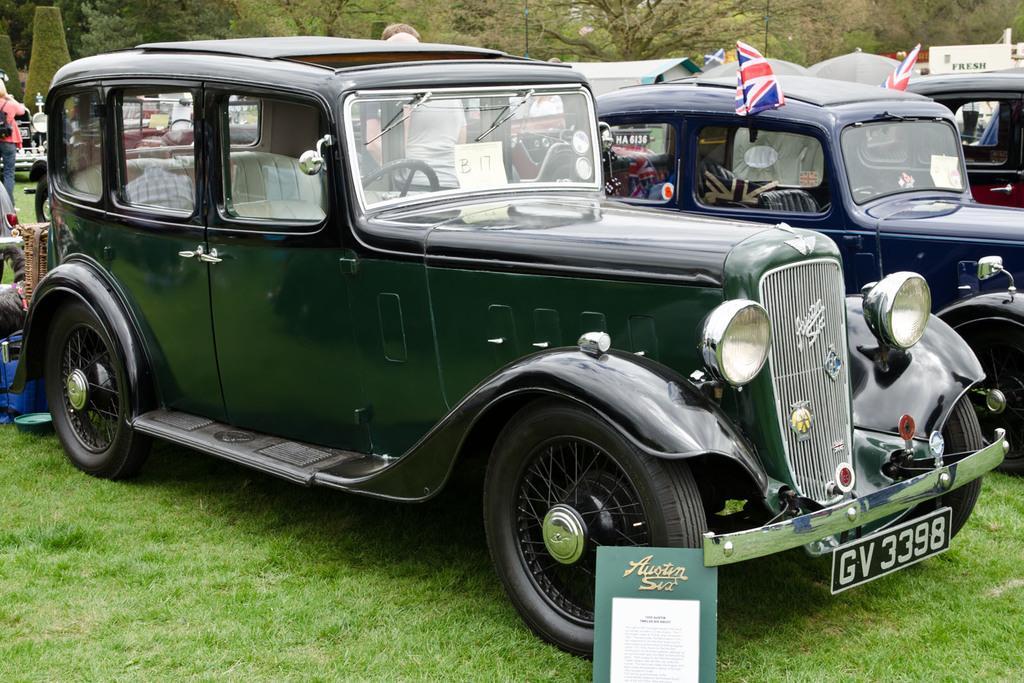Can you describe this image briefly? This picture is clicked outside. In the center there are many number of vehicles parked on the ground. In the foreground there is a board placed on the ground. In the background there are some objects placed on the ground and we can see the persons and the trees. 